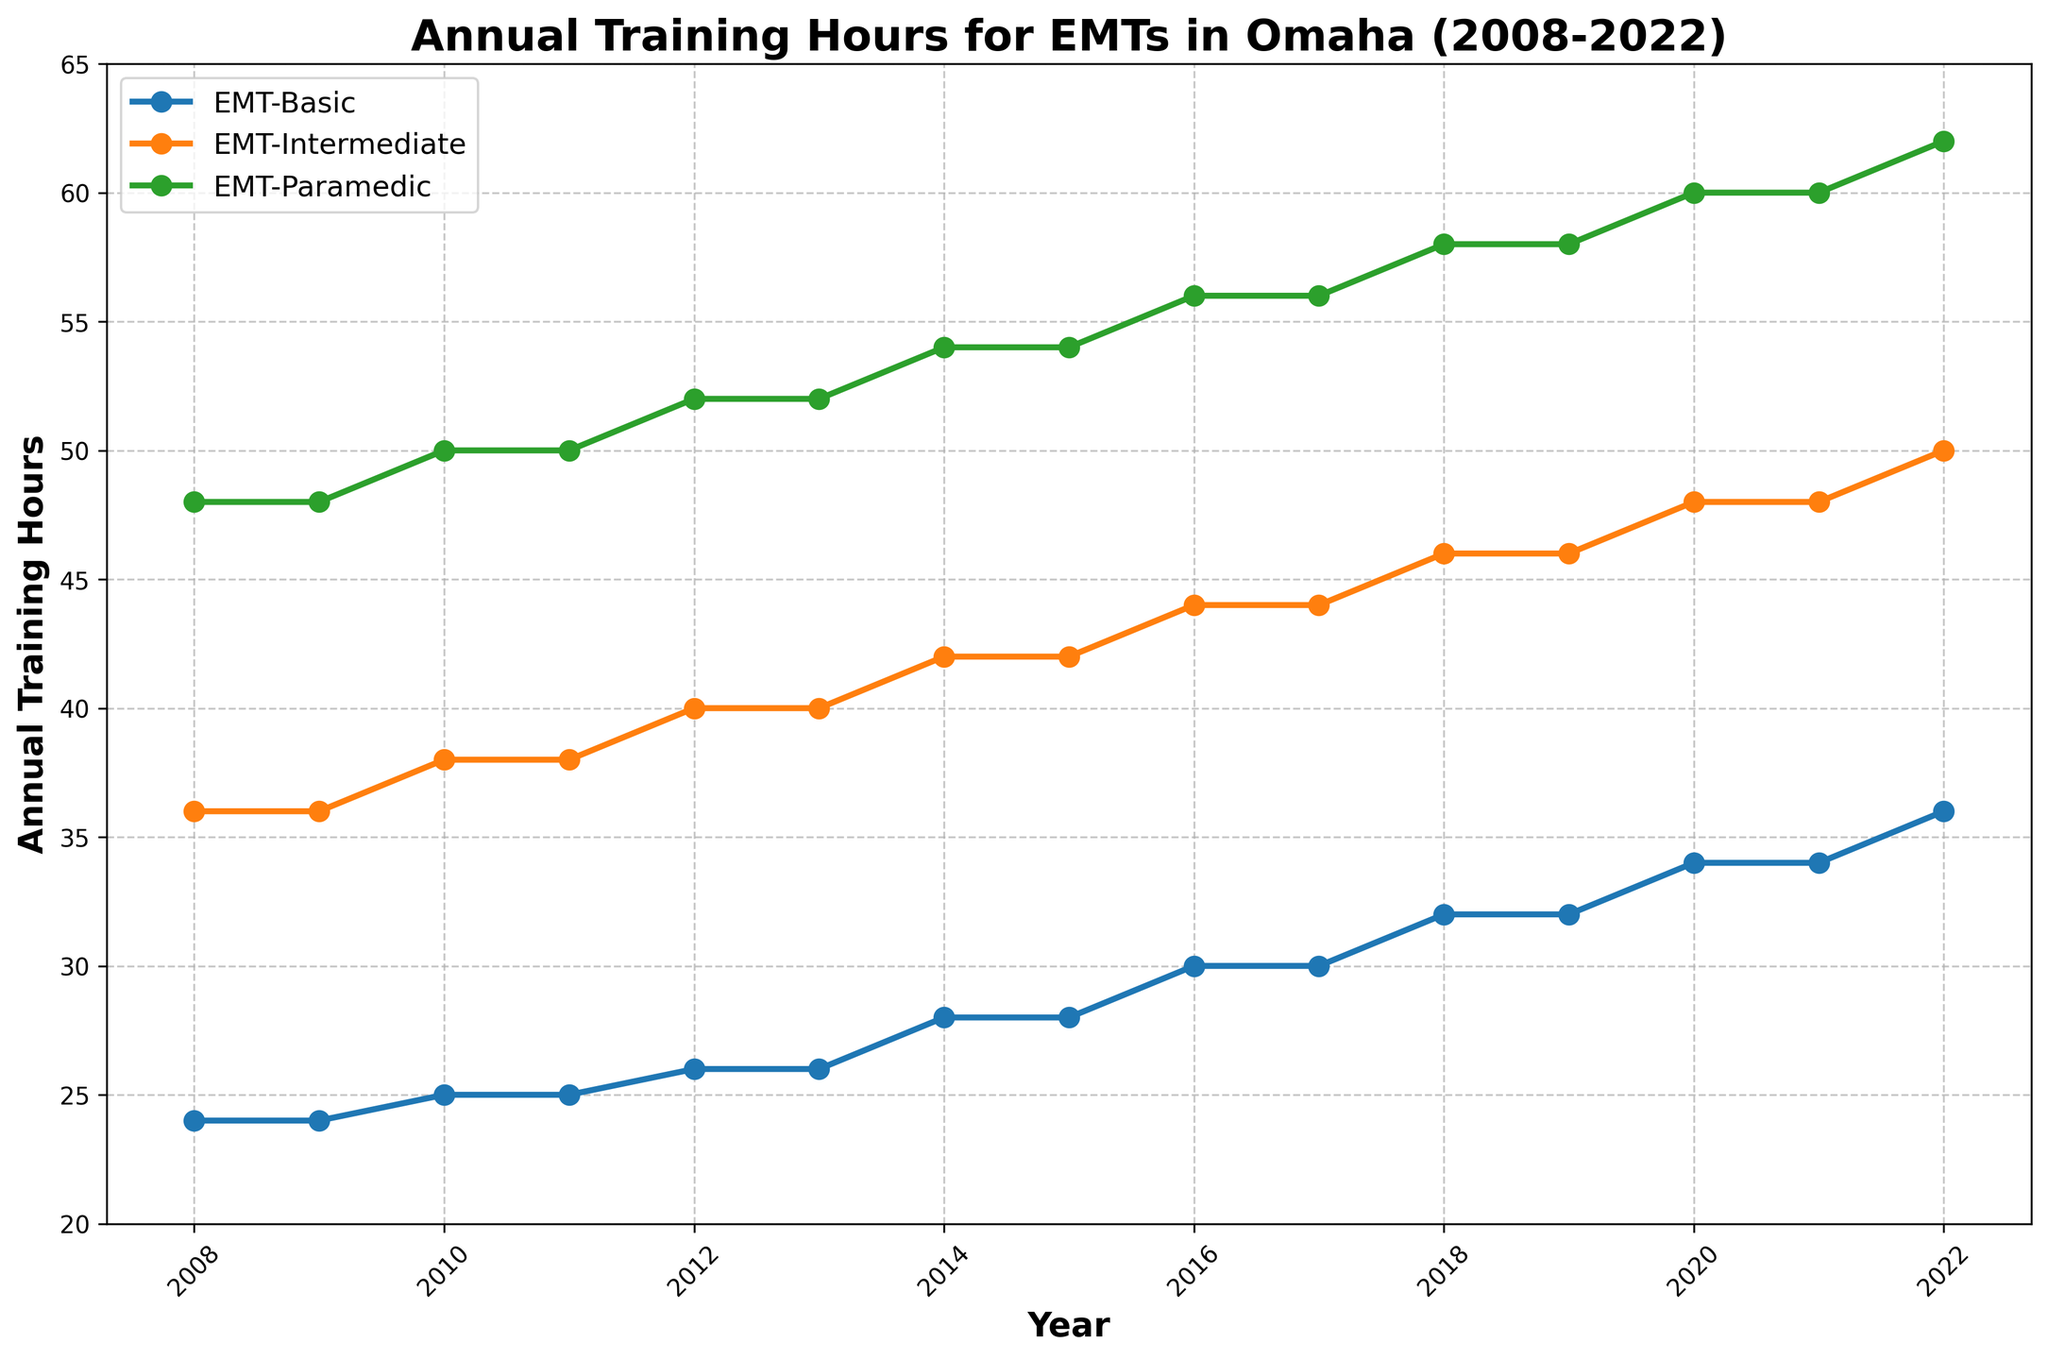How do the annual training hours for EMT-Basic compare to EMT-Paramedic in 2008? In 2008, the training hours for EMT-Basic are 24, and for EMT-Paramedic, they are 48. We can see that EMT-Paramedics need to complete twice as many hours as EMT-Basics in that year.
Answer: EMT-Paramedic has more hours What is the total increase in annual training hours for EMT-Intermediate from 2008 to 2022? In 2008, the training hours for EMT-Intermediate are 36. In 2022, they are 50. The difference between 2022 and 2008 is 50 - 36 = 14 hours.
Answer: 14 hours Which certification level had the highest annual training hours in 2014? In 2014, we see from the figure that EMT-Paramedic had the highest training hours with 54 hours.
Answer: EMT-Paramedic What is the average annual training hours completed by EMTs at the Basic level over the entire period (2008-2022)? Summing the training hours for EMT-Basic from 2008 to 2022 and then dividing by 15 (number of years) [(24 + 24 + 25 + 25 + 26 + 26 + 28 + 28 + 30 + 30 + 32 + 32 + 34 + 34 + 36) / 15 ] = 29.2
Answer: 29.2 hours In which year did EMT-Paramedics see a significant increase in their annual training hours compared to the previous year(s)? From the figure, we can see a significant increase between 2012 (52 hours) and 2013 (54 hours).
Answer: 2012-2013 Which certification level had equal training hours every two consecutive years? EMT-Basic had equal training hours every two consecutive years (e.g., 2008-2009, 2010-2011, etc.).
Answer: EMT-Basic How does the trend of training hours for EMT-Intermediate compare to the other two certification levels over the 15 years? EMT-Intermediate shows a gradual increase similar to EMT-Paramedic but at a lower pace compared to EMT-Basic, which shows steady, consistent increments every few years.
Answer: Gradual increase What is the difference in annual training hours between EMT-Intermediate and EMT-Paramedic in the year 2020? In 2020, EMT-Intermediate had 48 hours and EMT-Paramedic had 60 hours. The difference is 60 - 48 = 12 hours.
Answer: 12 hours In which year did the EMT-Basic level reach training hours above 30 for the first time? From the figure, EMT-Basic first exceeds 30 hours in the year 2016 with 30 hours.
Answer: 2016 